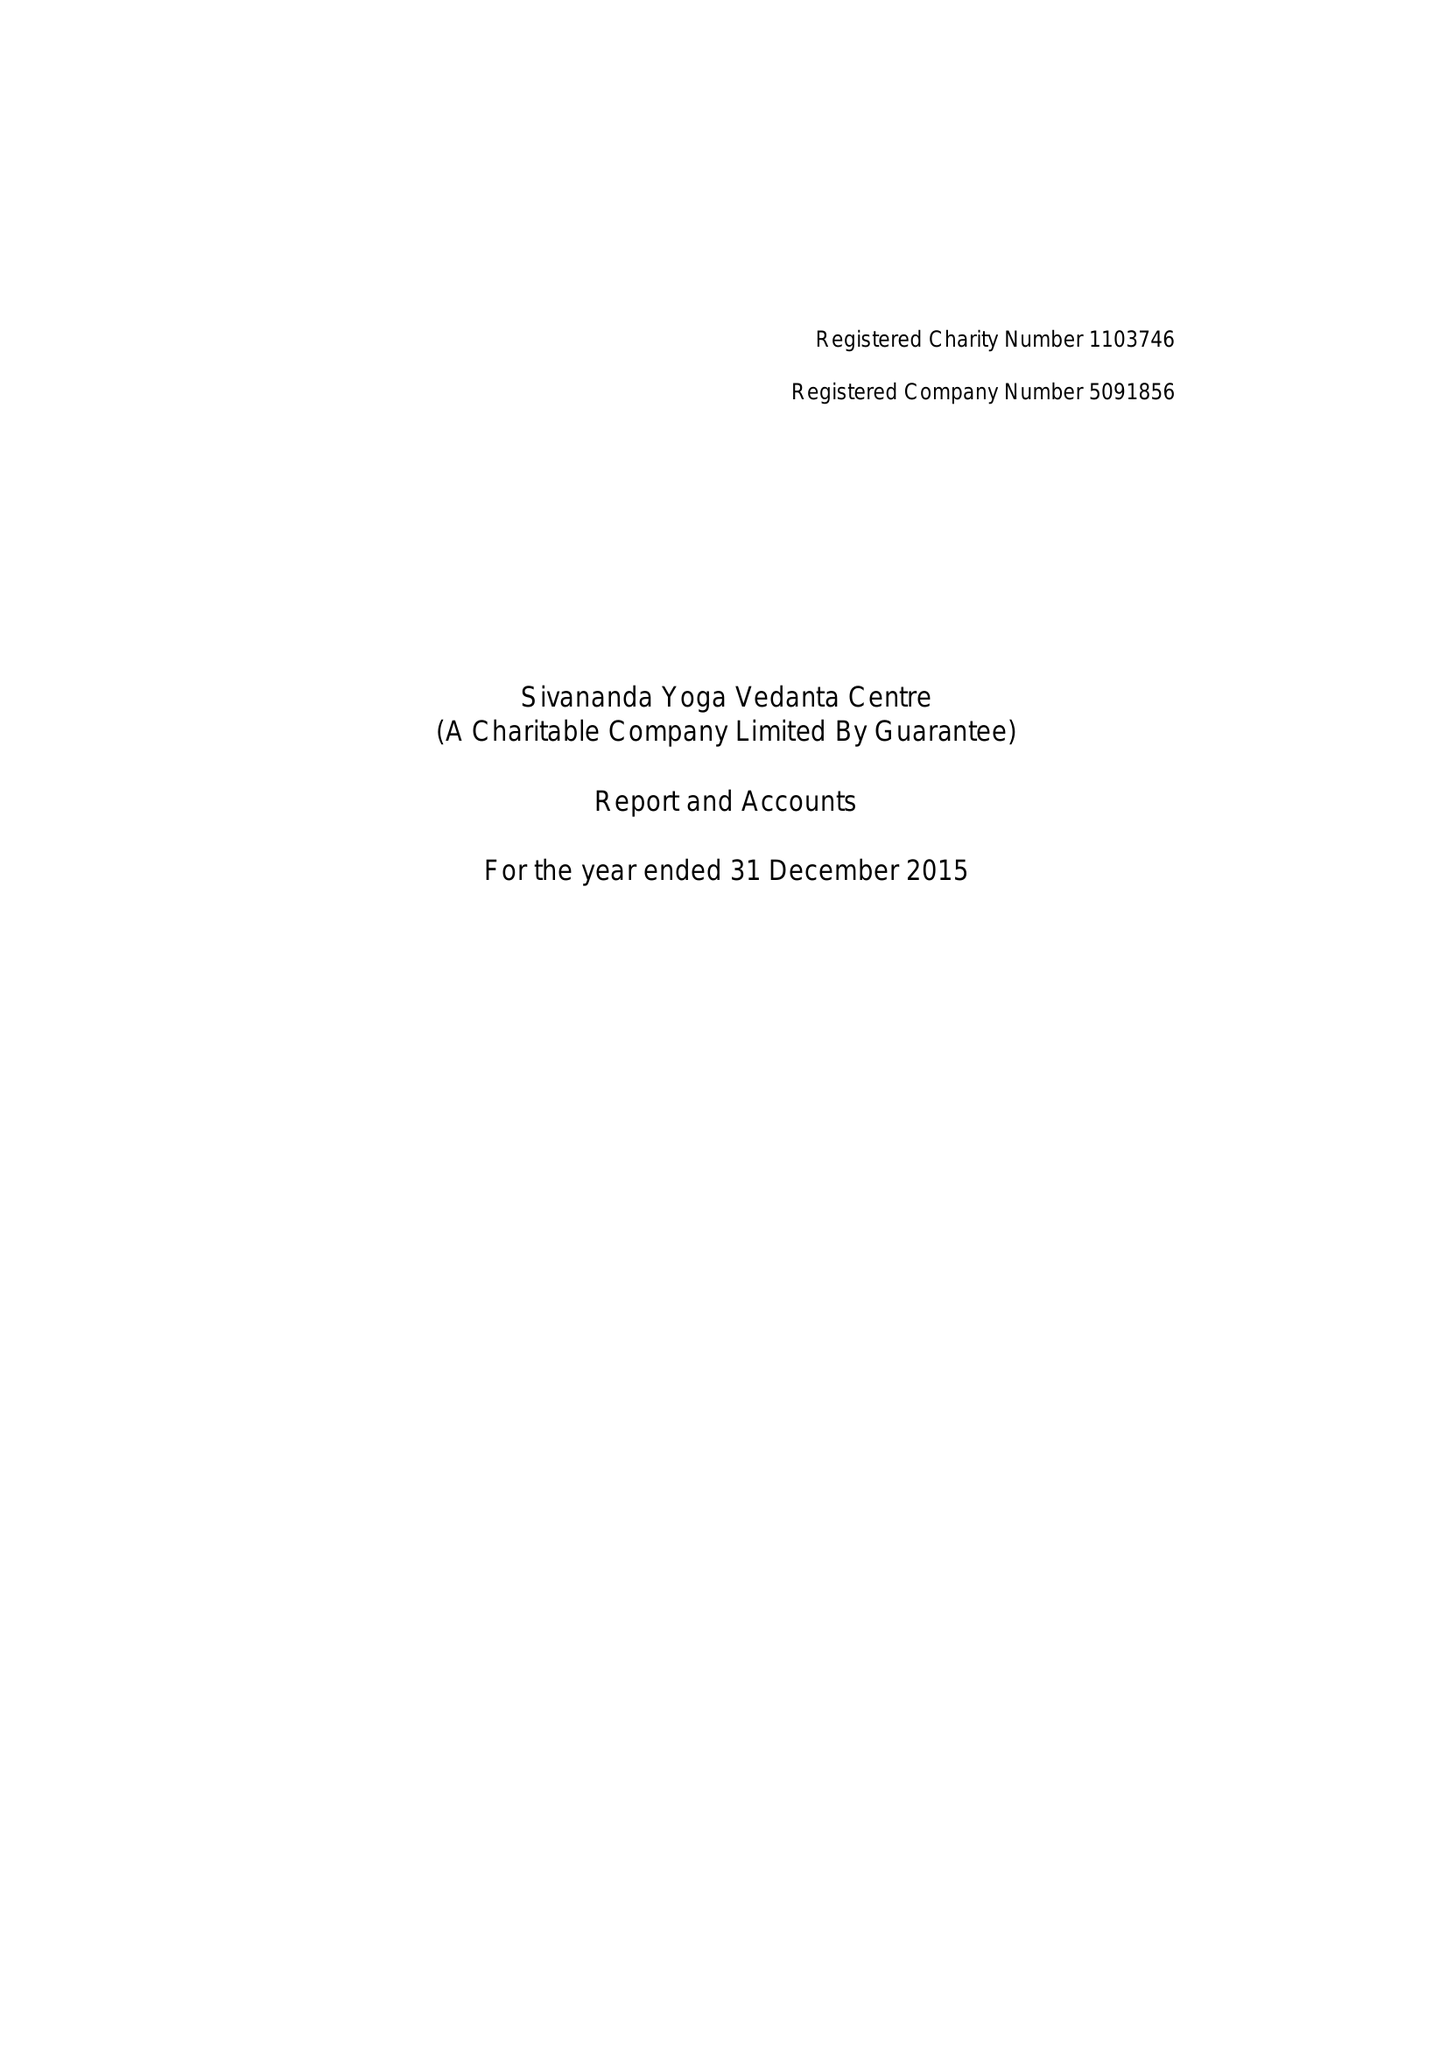What is the value for the charity_name?
Answer the question using a single word or phrase. Sivananda Yoga Vedanta Centre 